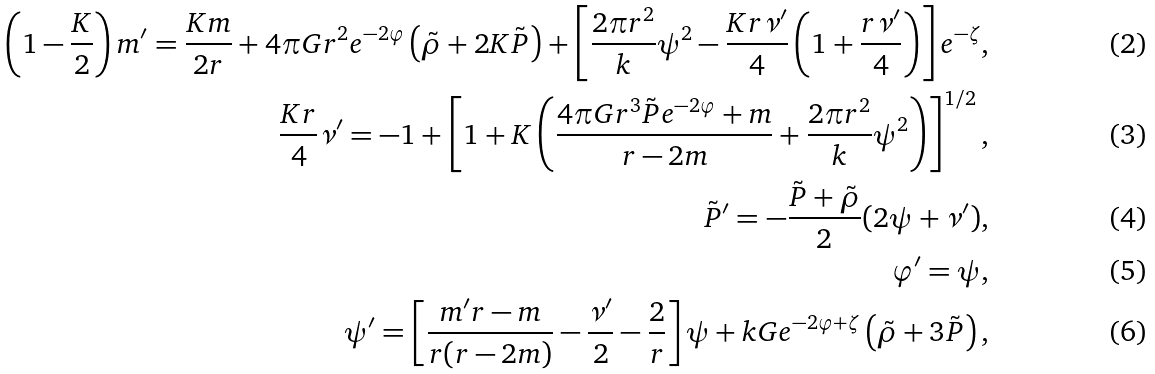<formula> <loc_0><loc_0><loc_500><loc_500>\left ( 1 - \frac { K } { 2 } \right ) m ^ { \prime } = \frac { K m } { 2 r } + 4 \pi G r ^ { 2 } e ^ { - 2 \varphi } \left ( \tilde { \rho } + 2 K \tilde { P } \right ) + \left [ \frac { 2 \pi r ^ { 2 } } { k } \psi ^ { 2 } - \frac { K r \nu ^ { \prime } } { 4 } \left ( 1 + \frac { r \nu ^ { \prime } } { 4 } \right ) \right ] e ^ { - \zeta } , \\ \frac { K r } { 4 } \nu ^ { \prime } = - 1 + \left [ 1 + K \left ( \frac { 4 \pi G r ^ { 3 } \tilde { P } e ^ { - 2 \varphi } + m } { r - 2 m } + \frac { 2 \pi r ^ { 2 } } { k } \psi ^ { 2 } \right ) \right ] ^ { 1 / 2 } , \\ \tilde { P } ^ { \prime } = - \frac { \tilde { P } + \tilde { \rho } } { 2 } ( 2 \psi + \nu ^ { \prime } ) , \\ \varphi ^ { \prime } = \psi , \\ \psi ^ { \prime } = \left [ \frac { m ^ { \prime } r - m } { r ( r - 2 m ) } - \frac { \nu ^ { \prime } } { 2 } - \frac { 2 } { r } \right ] \psi + k G e ^ { - 2 \varphi + \zeta } \left ( \tilde { \rho } + 3 \tilde { P } \right ) ,</formula> 